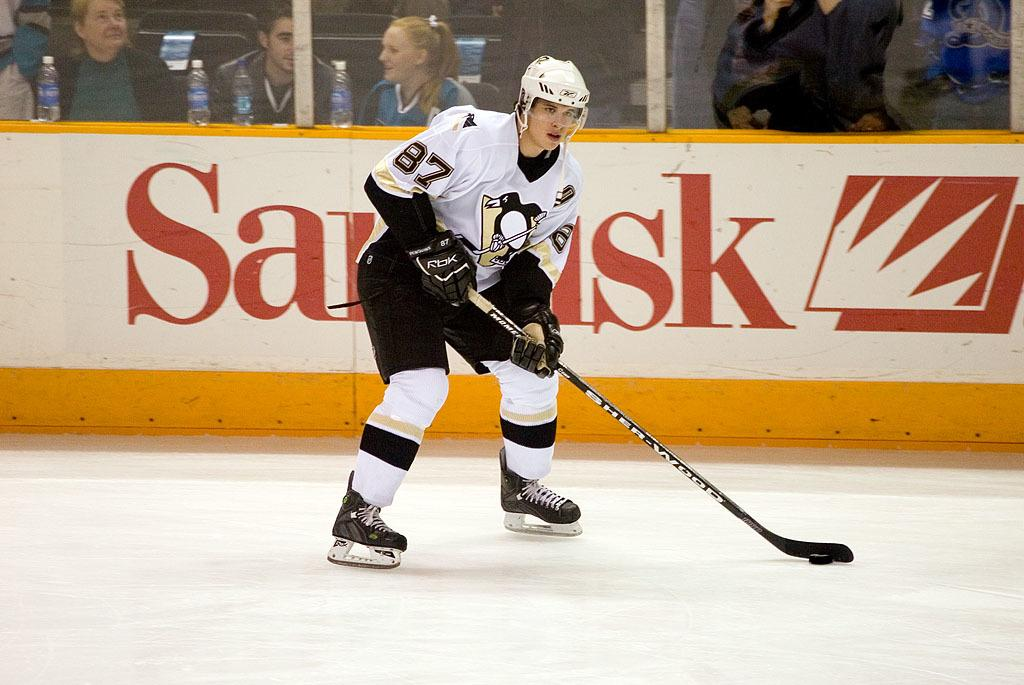Who is the main subject in the image? There is a man in the image. What is the man doing in the image? The man is playing hockey. What object is the man holding in the image? The man has a hockey stick in his hand. Can you describe the background of the image? There are people in the background of the image. What additional object can be seen in the image? There is a bottle placed on the wall in the image. Where is the grandmother in the image? There is no grandmother present in the image. How many goldfish are swimming in the image? There are no goldfish present in the image. 